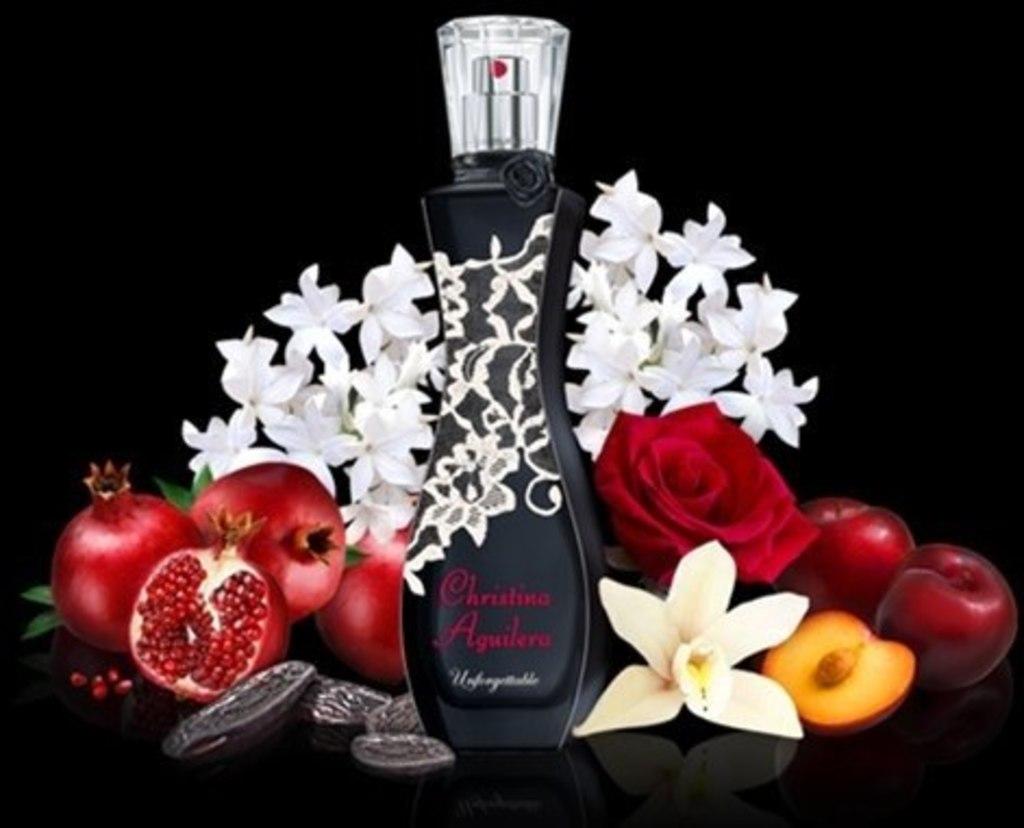What name is written in red on the perfume bottle?
Provide a short and direct response. Christina aguilera. 